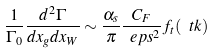Convert formula to latex. <formula><loc_0><loc_0><loc_500><loc_500>\frac { 1 } { \Gamma _ { 0 } } \frac { d ^ { 2 } \Gamma } { d x _ { g } d x _ { W } } \sim \frac { \alpha _ { s } } { \pi } \frac { C _ { F } } { \ e p s ^ { 2 } } f _ { t } ( \ t k )</formula> 